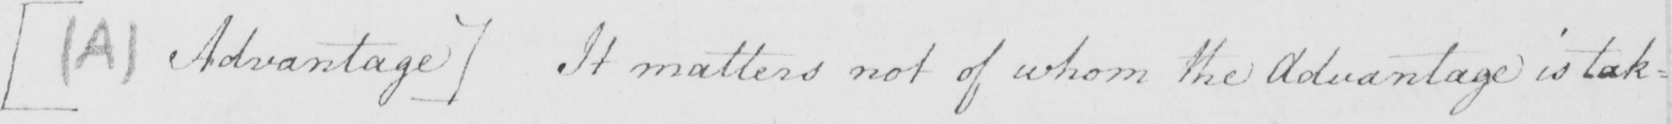Can you tell me what this handwritten text says? [  ( A )  Advantage ]  It matters not of whom the Advantage is tak= 